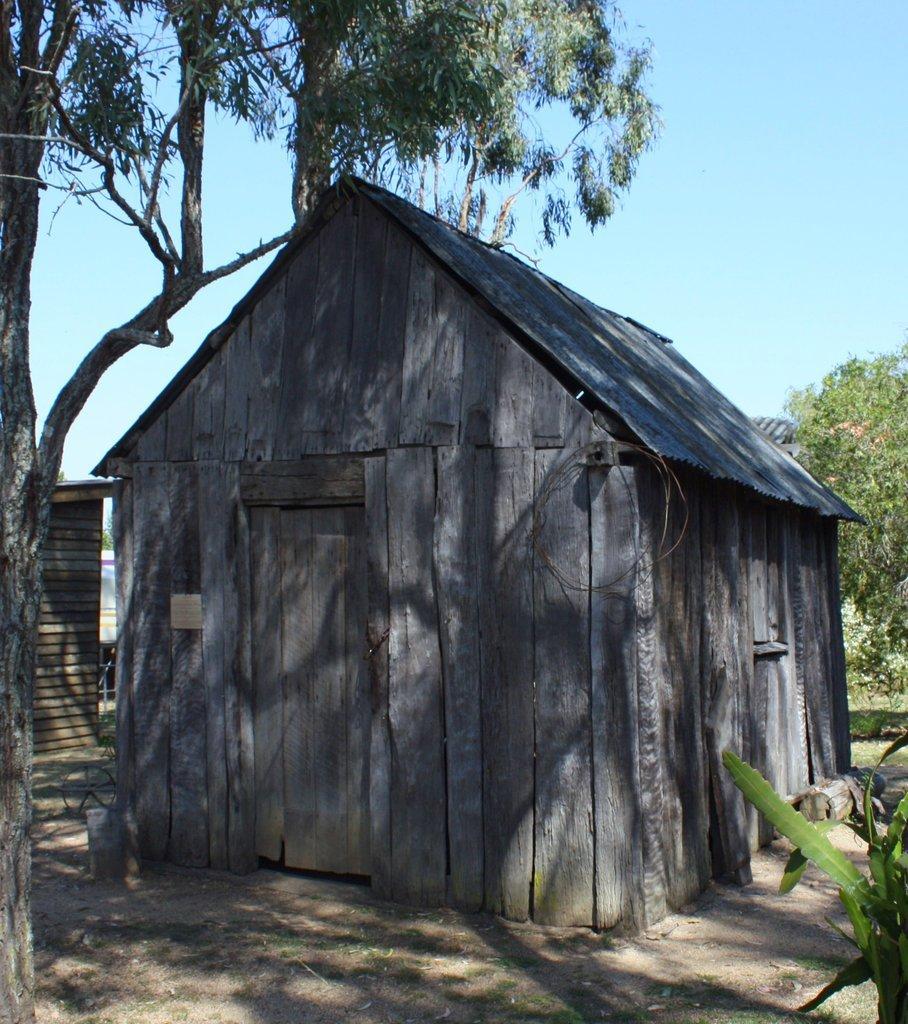Can you describe this image briefly? In this image there is the sky towards the top of the image, there is a tree towards the right of the image, there is a tree towards the left of the image, there is a plant towards the right of the image, there is a wooden house, there is a wall towards the left of the image. 